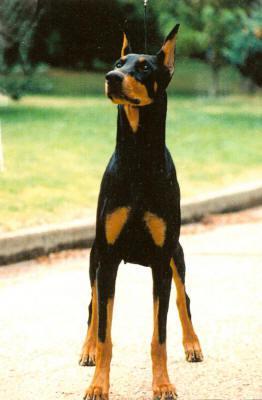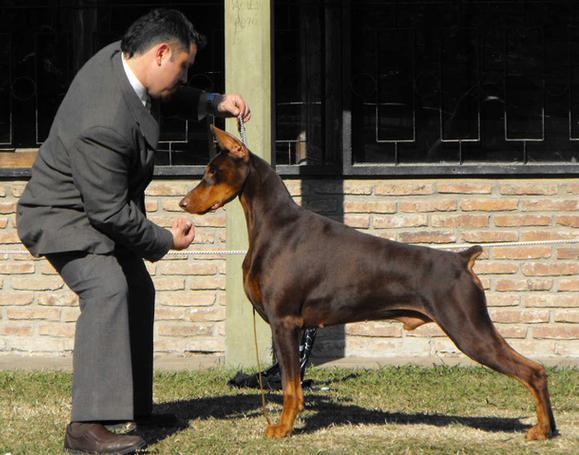The first image is the image on the left, the second image is the image on the right. Examine the images to the left and right. Is the description "there are two dogs side by side , at least one dog has dog tags on it's collar" accurate? Answer yes or no. No. The first image is the image on the left, the second image is the image on the right. Considering the images on both sides, is "One dog stands alone in the image on the left, and the right image shows a person standing by at least one doberman." valid? Answer yes or no. Yes. 